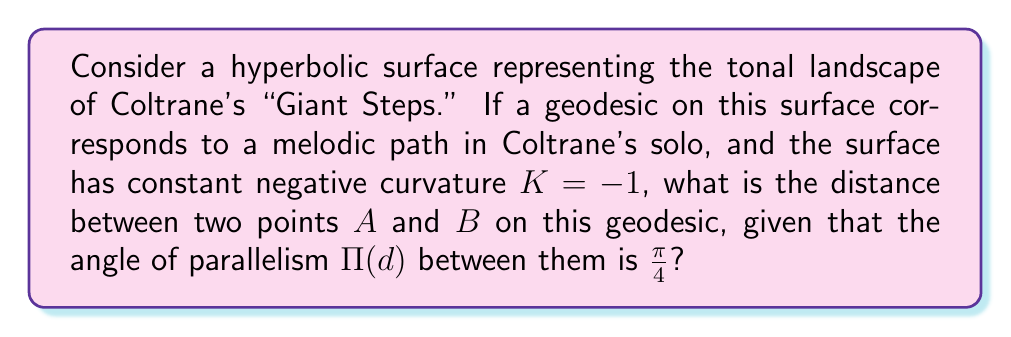Could you help me with this problem? Let's approach this step-by-step, drawing parallels to Coltrane's innovative harmonic progressions:

1) In hyperbolic geometry, the angle of parallelism $\Pi(d)$ is related to the distance $d$ by the formula:

   $$\Pi(d) = 2 \arctan(e^{-d})$$

2) We're given that $\Pi(d) = \frac{\pi}{4}$. Let's substitute this into the equation:

   $$\frac{\pi}{4} = 2 \arctan(e^{-d})$$

3) Solving for $d$:
   
   $$\frac{\pi}{8} = \arctan(e^{-d})$$

4) Taking the tangent of both sides:

   $$\tan(\frac{\pi}{8}) = e^{-d}$$

5) Now, let's take the natural log of both sides:

   $$\ln(\tan(\frac{\pi}{8})) = -d$$

6) Solving for $d$:

   $$d = -\ln(\tan(\frac{\pi}{8}))$$

7) We can simplify this further:

   $$d = \ln(\cot(\frac{\pi}{8}))$$

Just as Coltrane's solos in "Giant Steps" navigate complex harmonic terrain with precision, this geodesic distance represents the most efficient path between two tonal points in our hyperbolic musical space.
Answer: $d = \ln(\cot(\frac{\pi}{8}))$ 